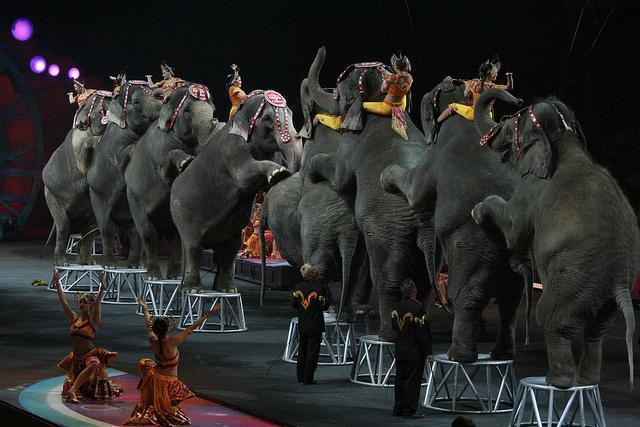What are the elephants doing?
Choose the right answer from the provided options to respond to the question.
Options: Foraging, performing, mating, stampeding. Performing. 